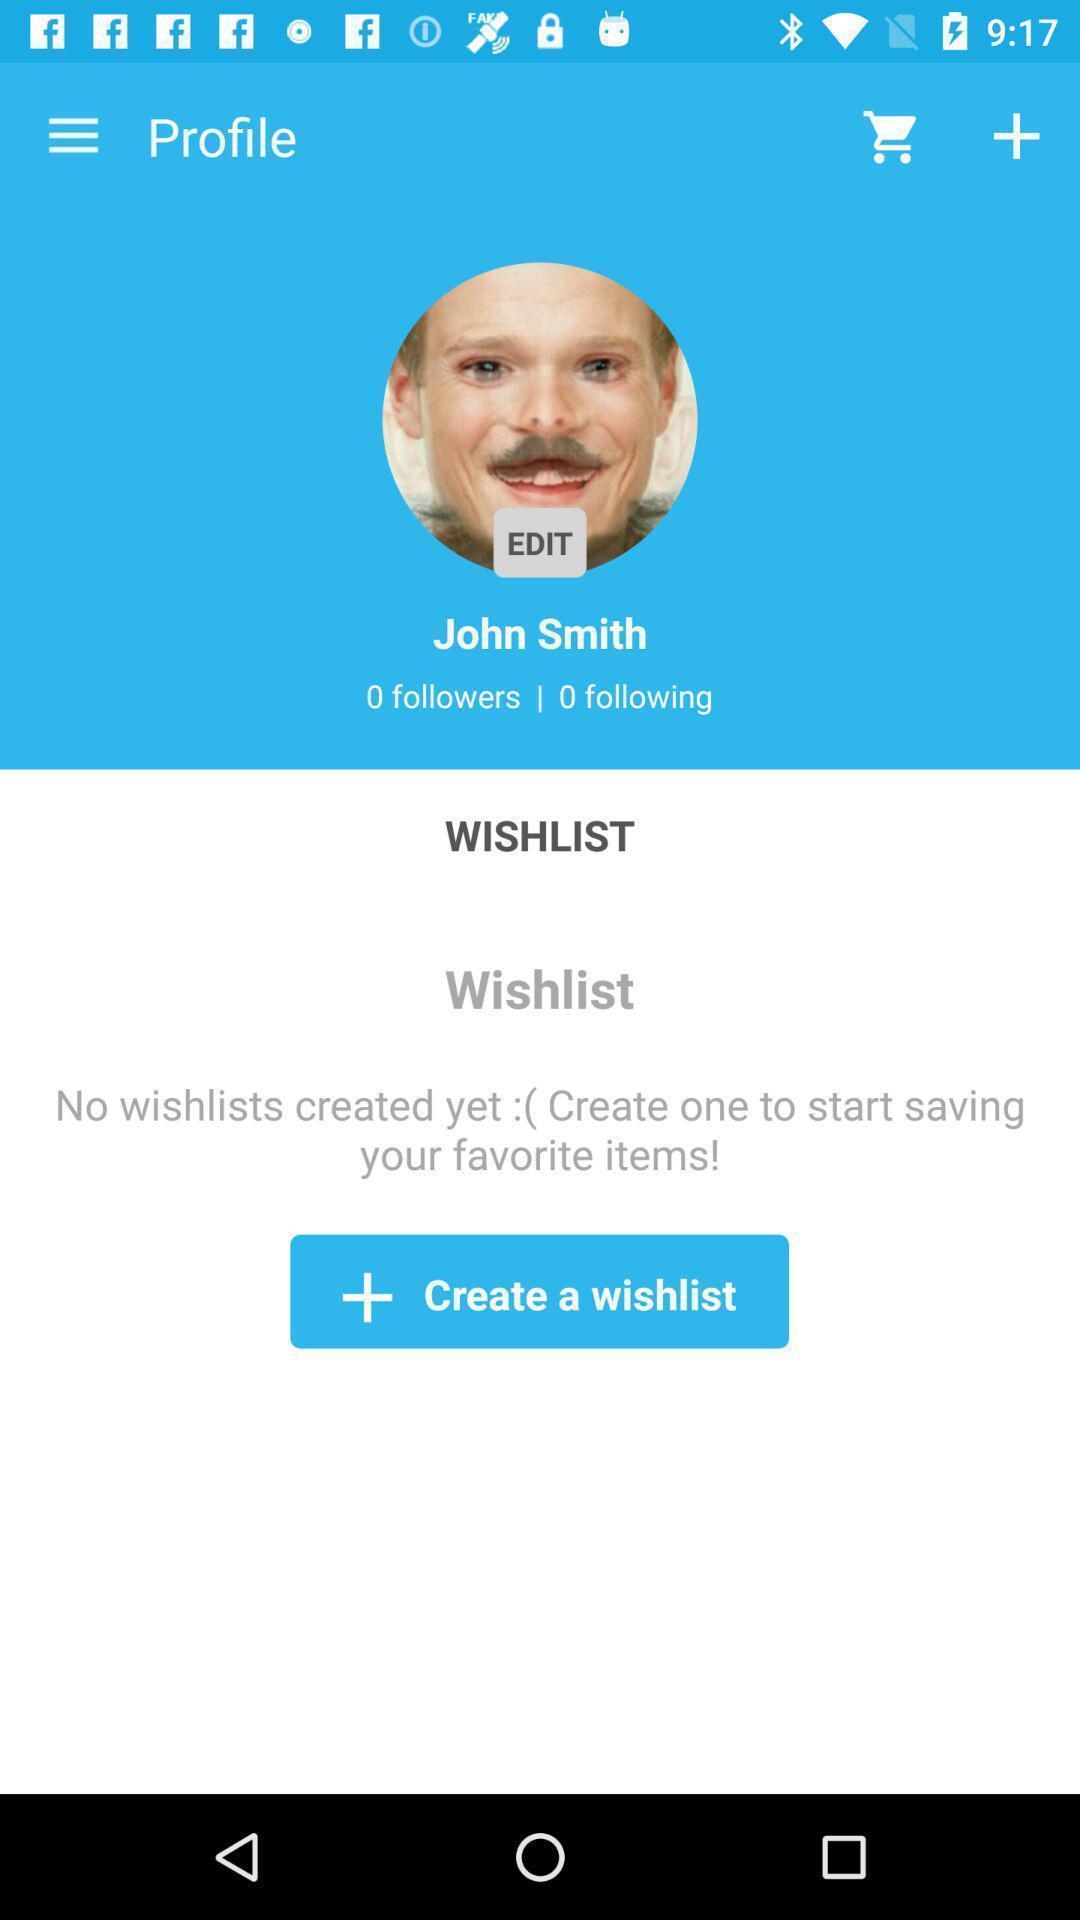What details can you identify in this image? Profile page displayed. 